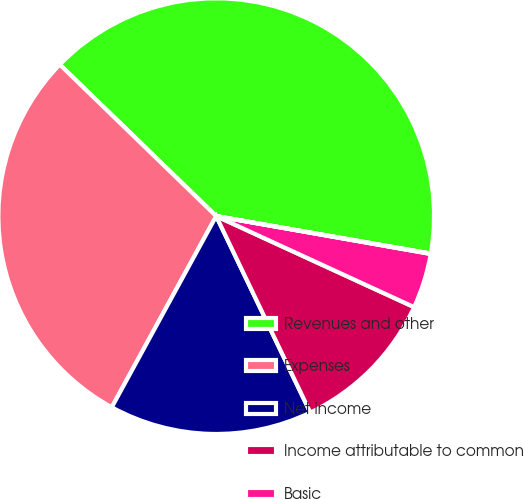Convert chart to OTSL. <chart><loc_0><loc_0><loc_500><loc_500><pie_chart><fcel>Revenues and other<fcel>Expenses<fcel>Net income<fcel>Income attributable to common<fcel>Basic<fcel>Diluted<nl><fcel>40.5%<fcel>29.29%<fcel>15.07%<fcel>11.03%<fcel>4.08%<fcel>0.03%<nl></chart> 